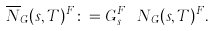Convert formula to latex. <formula><loc_0><loc_0><loc_500><loc_500>\overline { N } _ { G } ( s , T ) ^ { F } \colon = G _ { s } ^ { F } \ N _ { G } ( s , T ) ^ { F } .</formula> 